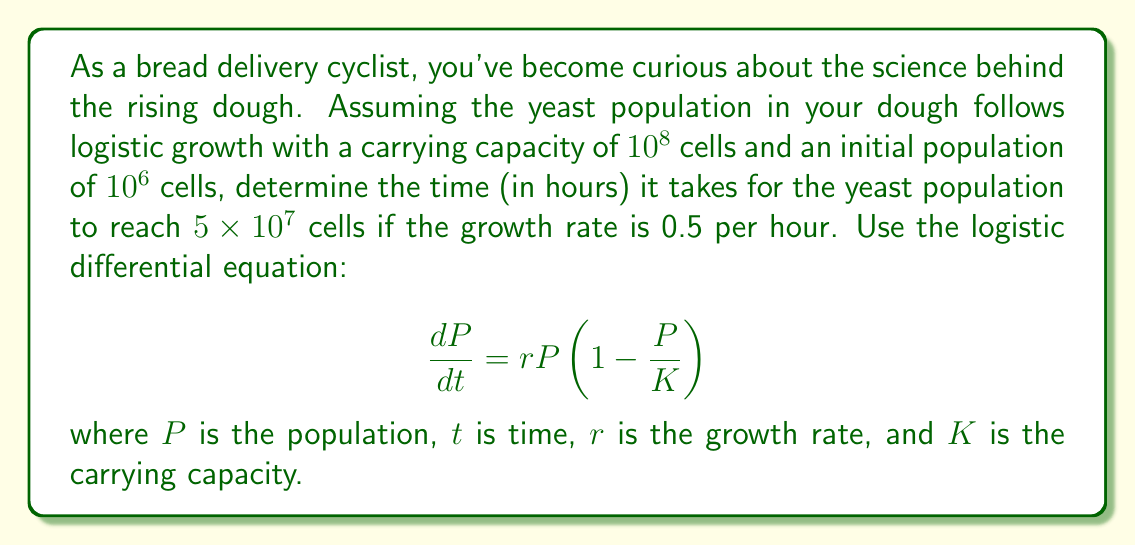Give your solution to this math problem. 1. We start with the logistic differential equation:
   $$\frac{dP}{dt} = rP(1 - \frac{P}{K})$$

2. Given information:
   - Initial population $P_0 = 10^6$ cells
   - Carrying capacity $K = 10^8$ cells
   - Growth rate $r = 0.5$ per hour
   - Target population $P = 5 \times 10^7$ cells

3. The solution to the logistic differential equation is:
   $$P(t) = \frac{K}{1 + (\frac{K}{P_0} - 1)e^{-rt}}$$

4. Substitute the known values:
   $$5 \times 10^7 = \frac{10^8}{1 + (\frac{10^8}{10^6} - 1)e^{-0.5t}}$$

5. Simplify:
   $$5 \times 10^7 = \frac{10^8}{1 + 99e^{-0.5t}}$$

6. Solve for $t$:
   $$1 + 99e^{-0.5t} = 2$$
   $$99e^{-0.5t} = 1$$
   $$e^{-0.5t} = \frac{1}{99}$$
   $$-0.5t = \ln(\frac{1}{99})$$
   $$t = -2\ln(\frac{1}{99}) = 2\ln(99)$$

7. Calculate the final value:
   $$t = 2 \times 4.5951 \approx 9.1902$$
Answer: 9.19 hours 